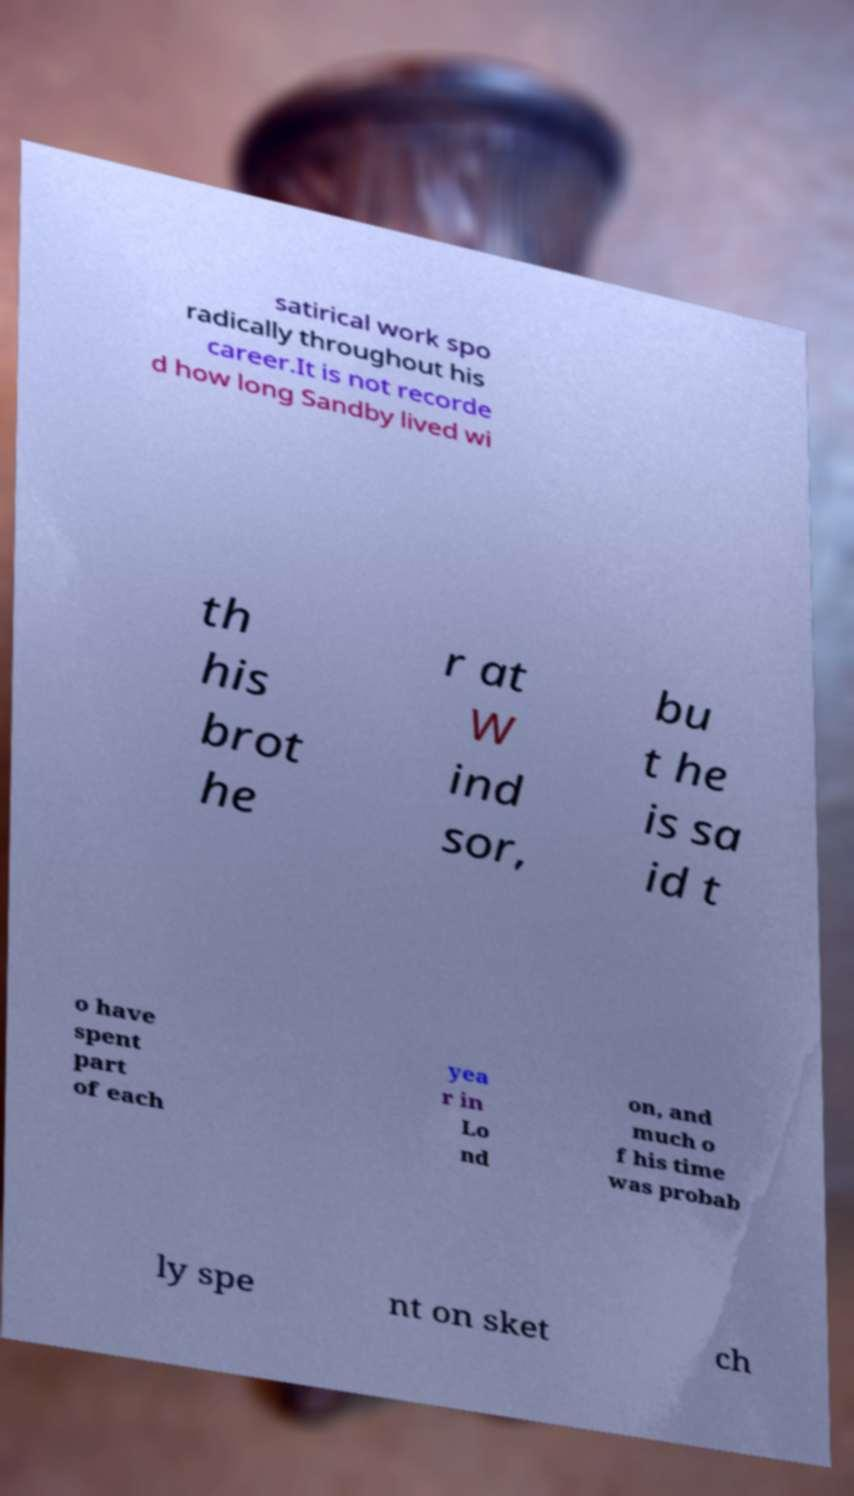For documentation purposes, I need the text within this image transcribed. Could you provide that? satirical work spo radically throughout his career.It is not recorde d how long Sandby lived wi th his brot he r at W ind sor, bu t he is sa id t o have spent part of each yea r in Lo nd on, and much o f his time was probab ly spe nt on sket ch 